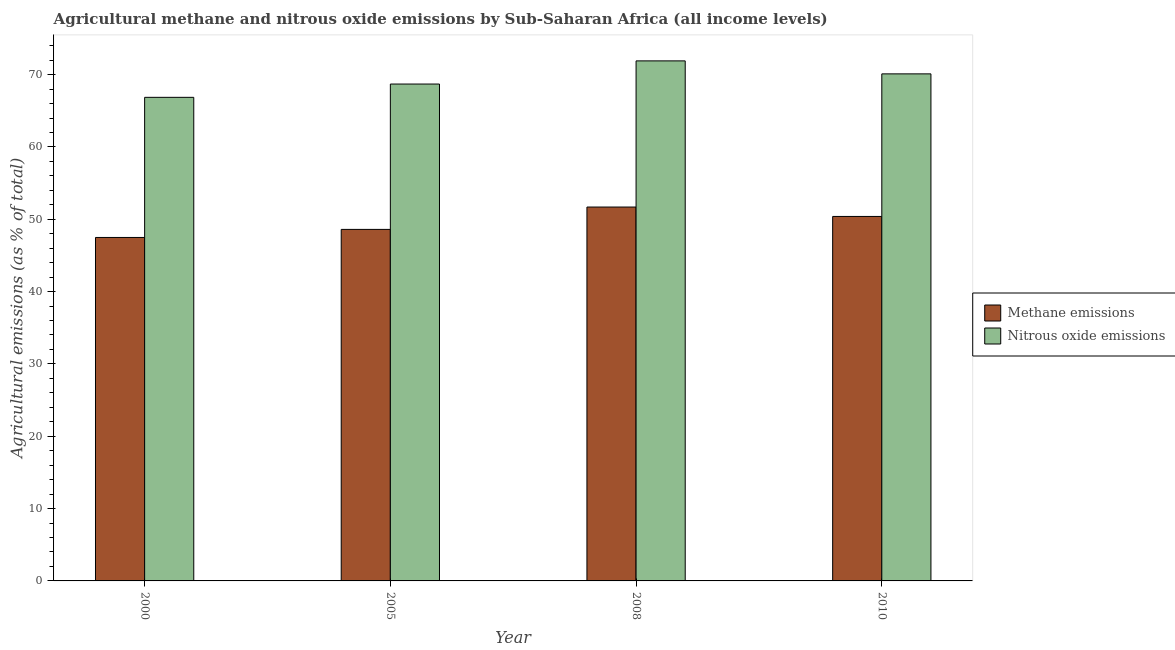How many different coloured bars are there?
Provide a short and direct response. 2. How many groups of bars are there?
Offer a very short reply. 4. Are the number of bars per tick equal to the number of legend labels?
Keep it short and to the point. Yes. Are the number of bars on each tick of the X-axis equal?
Your response must be concise. Yes. What is the label of the 1st group of bars from the left?
Ensure brevity in your answer.  2000. What is the amount of nitrous oxide emissions in 2008?
Offer a very short reply. 71.9. Across all years, what is the maximum amount of methane emissions?
Offer a very short reply. 51.69. Across all years, what is the minimum amount of methane emissions?
Provide a short and direct response. 47.48. What is the total amount of methane emissions in the graph?
Your answer should be very brief. 198.16. What is the difference between the amount of methane emissions in 2000 and that in 2005?
Make the answer very short. -1.12. What is the difference between the amount of nitrous oxide emissions in 2005 and the amount of methane emissions in 2010?
Your answer should be compact. -1.41. What is the average amount of methane emissions per year?
Your answer should be very brief. 49.54. In the year 2010, what is the difference between the amount of nitrous oxide emissions and amount of methane emissions?
Offer a terse response. 0. What is the ratio of the amount of methane emissions in 2005 to that in 2008?
Your response must be concise. 0.94. Is the difference between the amount of nitrous oxide emissions in 2005 and 2008 greater than the difference between the amount of methane emissions in 2005 and 2008?
Offer a very short reply. No. What is the difference between the highest and the second highest amount of nitrous oxide emissions?
Provide a short and direct response. 1.79. What is the difference between the highest and the lowest amount of methane emissions?
Make the answer very short. 4.21. In how many years, is the amount of nitrous oxide emissions greater than the average amount of nitrous oxide emissions taken over all years?
Ensure brevity in your answer.  2. What does the 1st bar from the left in 2010 represents?
Provide a short and direct response. Methane emissions. What does the 1st bar from the right in 2000 represents?
Your answer should be very brief. Nitrous oxide emissions. How many bars are there?
Make the answer very short. 8. Are all the bars in the graph horizontal?
Provide a succinct answer. No. How many years are there in the graph?
Offer a terse response. 4. Are the values on the major ticks of Y-axis written in scientific E-notation?
Provide a succinct answer. No. Does the graph contain any zero values?
Your response must be concise. No. Where does the legend appear in the graph?
Provide a short and direct response. Center right. How are the legend labels stacked?
Your answer should be compact. Vertical. What is the title of the graph?
Offer a very short reply. Agricultural methane and nitrous oxide emissions by Sub-Saharan Africa (all income levels). What is the label or title of the Y-axis?
Your answer should be very brief. Agricultural emissions (as % of total). What is the Agricultural emissions (as % of total) in Methane emissions in 2000?
Provide a short and direct response. 47.48. What is the Agricultural emissions (as % of total) in Nitrous oxide emissions in 2000?
Provide a short and direct response. 66.86. What is the Agricultural emissions (as % of total) of Methane emissions in 2005?
Make the answer very short. 48.6. What is the Agricultural emissions (as % of total) of Nitrous oxide emissions in 2005?
Your answer should be compact. 68.7. What is the Agricultural emissions (as % of total) in Methane emissions in 2008?
Provide a short and direct response. 51.69. What is the Agricultural emissions (as % of total) of Nitrous oxide emissions in 2008?
Offer a very short reply. 71.9. What is the Agricultural emissions (as % of total) of Methane emissions in 2010?
Offer a very short reply. 50.39. What is the Agricultural emissions (as % of total) of Nitrous oxide emissions in 2010?
Make the answer very short. 70.1. Across all years, what is the maximum Agricultural emissions (as % of total) in Methane emissions?
Offer a terse response. 51.69. Across all years, what is the maximum Agricultural emissions (as % of total) of Nitrous oxide emissions?
Make the answer very short. 71.9. Across all years, what is the minimum Agricultural emissions (as % of total) in Methane emissions?
Provide a short and direct response. 47.48. Across all years, what is the minimum Agricultural emissions (as % of total) of Nitrous oxide emissions?
Offer a very short reply. 66.86. What is the total Agricultural emissions (as % of total) in Methane emissions in the graph?
Your answer should be compact. 198.16. What is the total Agricultural emissions (as % of total) of Nitrous oxide emissions in the graph?
Your answer should be very brief. 277.56. What is the difference between the Agricultural emissions (as % of total) of Methane emissions in 2000 and that in 2005?
Offer a terse response. -1.12. What is the difference between the Agricultural emissions (as % of total) in Nitrous oxide emissions in 2000 and that in 2005?
Offer a terse response. -1.84. What is the difference between the Agricultural emissions (as % of total) of Methane emissions in 2000 and that in 2008?
Provide a succinct answer. -4.21. What is the difference between the Agricultural emissions (as % of total) in Nitrous oxide emissions in 2000 and that in 2008?
Your response must be concise. -5.04. What is the difference between the Agricultural emissions (as % of total) in Methane emissions in 2000 and that in 2010?
Offer a terse response. -2.91. What is the difference between the Agricultural emissions (as % of total) of Nitrous oxide emissions in 2000 and that in 2010?
Your response must be concise. -3.24. What is the difference between the Agricultural emissions (as % of total) in Methane emissions in 2005 and that in 2008?
Offer a terse response. -3.09. What is the difference between the Agricultural emissions (as % of total) of Nitrous oxide emissions in 2005 and that in 2008?
Provide a succinct answer. -3.2. What is the difference between the Agricultural emissions (as % of total) in Methane emissions in 2005 and that in 2010?
Ensure brevity in your answer.  -1.79. What is the difference between the Agricultural emissions (as % of total) in Nitrous oxide emissions in 2005 and that in 2010?
Provide a short and direct response. -1.41. What is the difference between the Agricultural emissions (as % of total) of Methane emissions in 2008 and that in 2010?
Your answer should be compact. 1.3. What is the difference between the Agricultural emissions (as % of total) in Nitrous oxide emissions in 2008 and that in 2010?
Ensure brevity in your answer.  1.79. What is the difference between the Agricultural emissions (as % of total) of Methane emissions in 2000 and the Agricultural emissions (as % of total) of Nitrous oxide emissions in 2005?
Offer a very short reply. -21.21. What is the difference between the Agricultural emissions (as % of total) of Methane emissions in 2000 and the Agricultural emissions (as % of total) of Nitrous oxide emissions in 2008?
Offer a terse response. -24.41. What is the difference between the Agricultural emissions (as % of total) in Methane emissions in 2000 and the Agricultural emissions (as % of total) in Nitrous oxide emissions in 2010?
Ensure brevity in your answer.  -22.62. What is the difference between the Agricultural emissions (as % of total) in Methane emissions in 2005 and the Agricultural emissions (as % of total) in Nitrous oxide emissions in 2008?
Offer a very short reply. -23.3. What is the difference between the Agricultural emissions (as % of total) in Methane emissions in 2005 and the Agricultural emissions (as % of total) in Nitrous oxide emissions in 2010?
Ensure brevity in your answer.  -21.5. What is the difference between the Agricultural emissions (as % of total) in Methane emissions in 2008 and the Agricultural emissions (as % of total) in Nitrous oxide emissions in 2010?
Provide a short and direct response. -18.41. What is the average Agricultural emissions (as % of total) in Methane emissions per year?
Provide a short and direct response. 49.54. What is the average Agricultural emissions (as % of total) of Nitrous oxide emissions per year?
Make the answer very short. 69.39. In the year 2000, what is the difference between the Agricultural emissions (as % of total) of Methane emissions and Agricultural emissions (as % of total) of Nitrous oxide emissions?
Your response must be concise. -19.37. In the year 2005, what is the difference between the Agricultural emissions (as % of total) of Methane emissions and Agricultural emissions (as % of total) of Nitrous oxide emissions?
Make the answer very short. -20.1. In the year 2008, what is the difference between the Agricultural emissions (as % of total) in Methane emissions and Agricultural emissions (as % of total) in Nitrous oxide emissions?
Provide a short and direct response. -20.21. In the year 2010, what is the difference between the Agricultural emissions (as % of total) of Methane emissions and Agricultural emissions (as % of total) of Nitrous oxide emissions?
Keep it short and to the point. -19.71. What is the ratio of the Agricultural emissions (as % of total) in Methane emissions in 2000 to that in 2005?
Make the answer very short. 0.98. What is the ratio of the Agricultural emissions (as % of total) of Nitrous oxide emissions in 2000 to that in 2005?
Keep it short and to the point. 0.97. What is the ratio of the Agricultural emissions (as % of total) in Methane emissions in 2000 to that in 2008?
Your answer should be very brief. 0.92. What is the ratio of the Agricultural emissions (as % of total) in Nitrous oxide emissions in 2000 to that in 2008?
Keep it short and to the point. 0.93. What is the ratio of the Agricultural emissions (as % of total) of Methane emissions in 2000 to that in 2010?
Provide a short and direct response. 0.94. What is the ratio of the Agricultural emissions (as % of total) of Nitrous oxide emissions in 2000 to that in 2010?
Ensure brevity in your answer.  0.95. What is the ratio of the Agricultural emissions (as % of total) of Methane emissions in 2005 to that in 2008?
Offer a very short reply. 0.94. What is the ratio of the Agricultural emissions (as % of total) in Nitrous oxide emissions in 2005 to that in 2008?
Your answer should be very brief. 0.96. What is the ratio of the Agricultural emissions (as % of total) in Methane emissions in 2005 to that in 2010?
Your answer should be very brief. 0.96. What is the ratio of the Agricultural emissions (as % of total) in Nitrous oxide emissions in 2005 to that in 2010?
Offer a terse response. 0.98. What is the ratio of the Agricultural emissions (as % of total) of Methane emissions in 2008 to that in 2010?
Ensure brevity in your answer.  1.03. What is the ratio of the Agricultural emissions (as % of total) in Nitrous oxide emissions in 2008 to that in 2010?
Make the answer very short. 1.03. What is the difference between the highest and the second highest Agricultural emissions (as % of total) in Methane emissions?
Ensure brevity in your answer.  1.3. What is the difference between the highest and the second highest Agricultural emissions (as % of total) of Nitrous oxide emissions?
Your answer should be compact. 1.79. What is the difference between the highest and the lowest Agricultural emissions (as % of total) of Methane emissions?
Provide a succinct answer. 4.21. What is the difference between the highest and the lowest Agricultural emissions (as % of total) in Nitrous oxide emissions?
Ensure brevity in your answer.  5.04. 